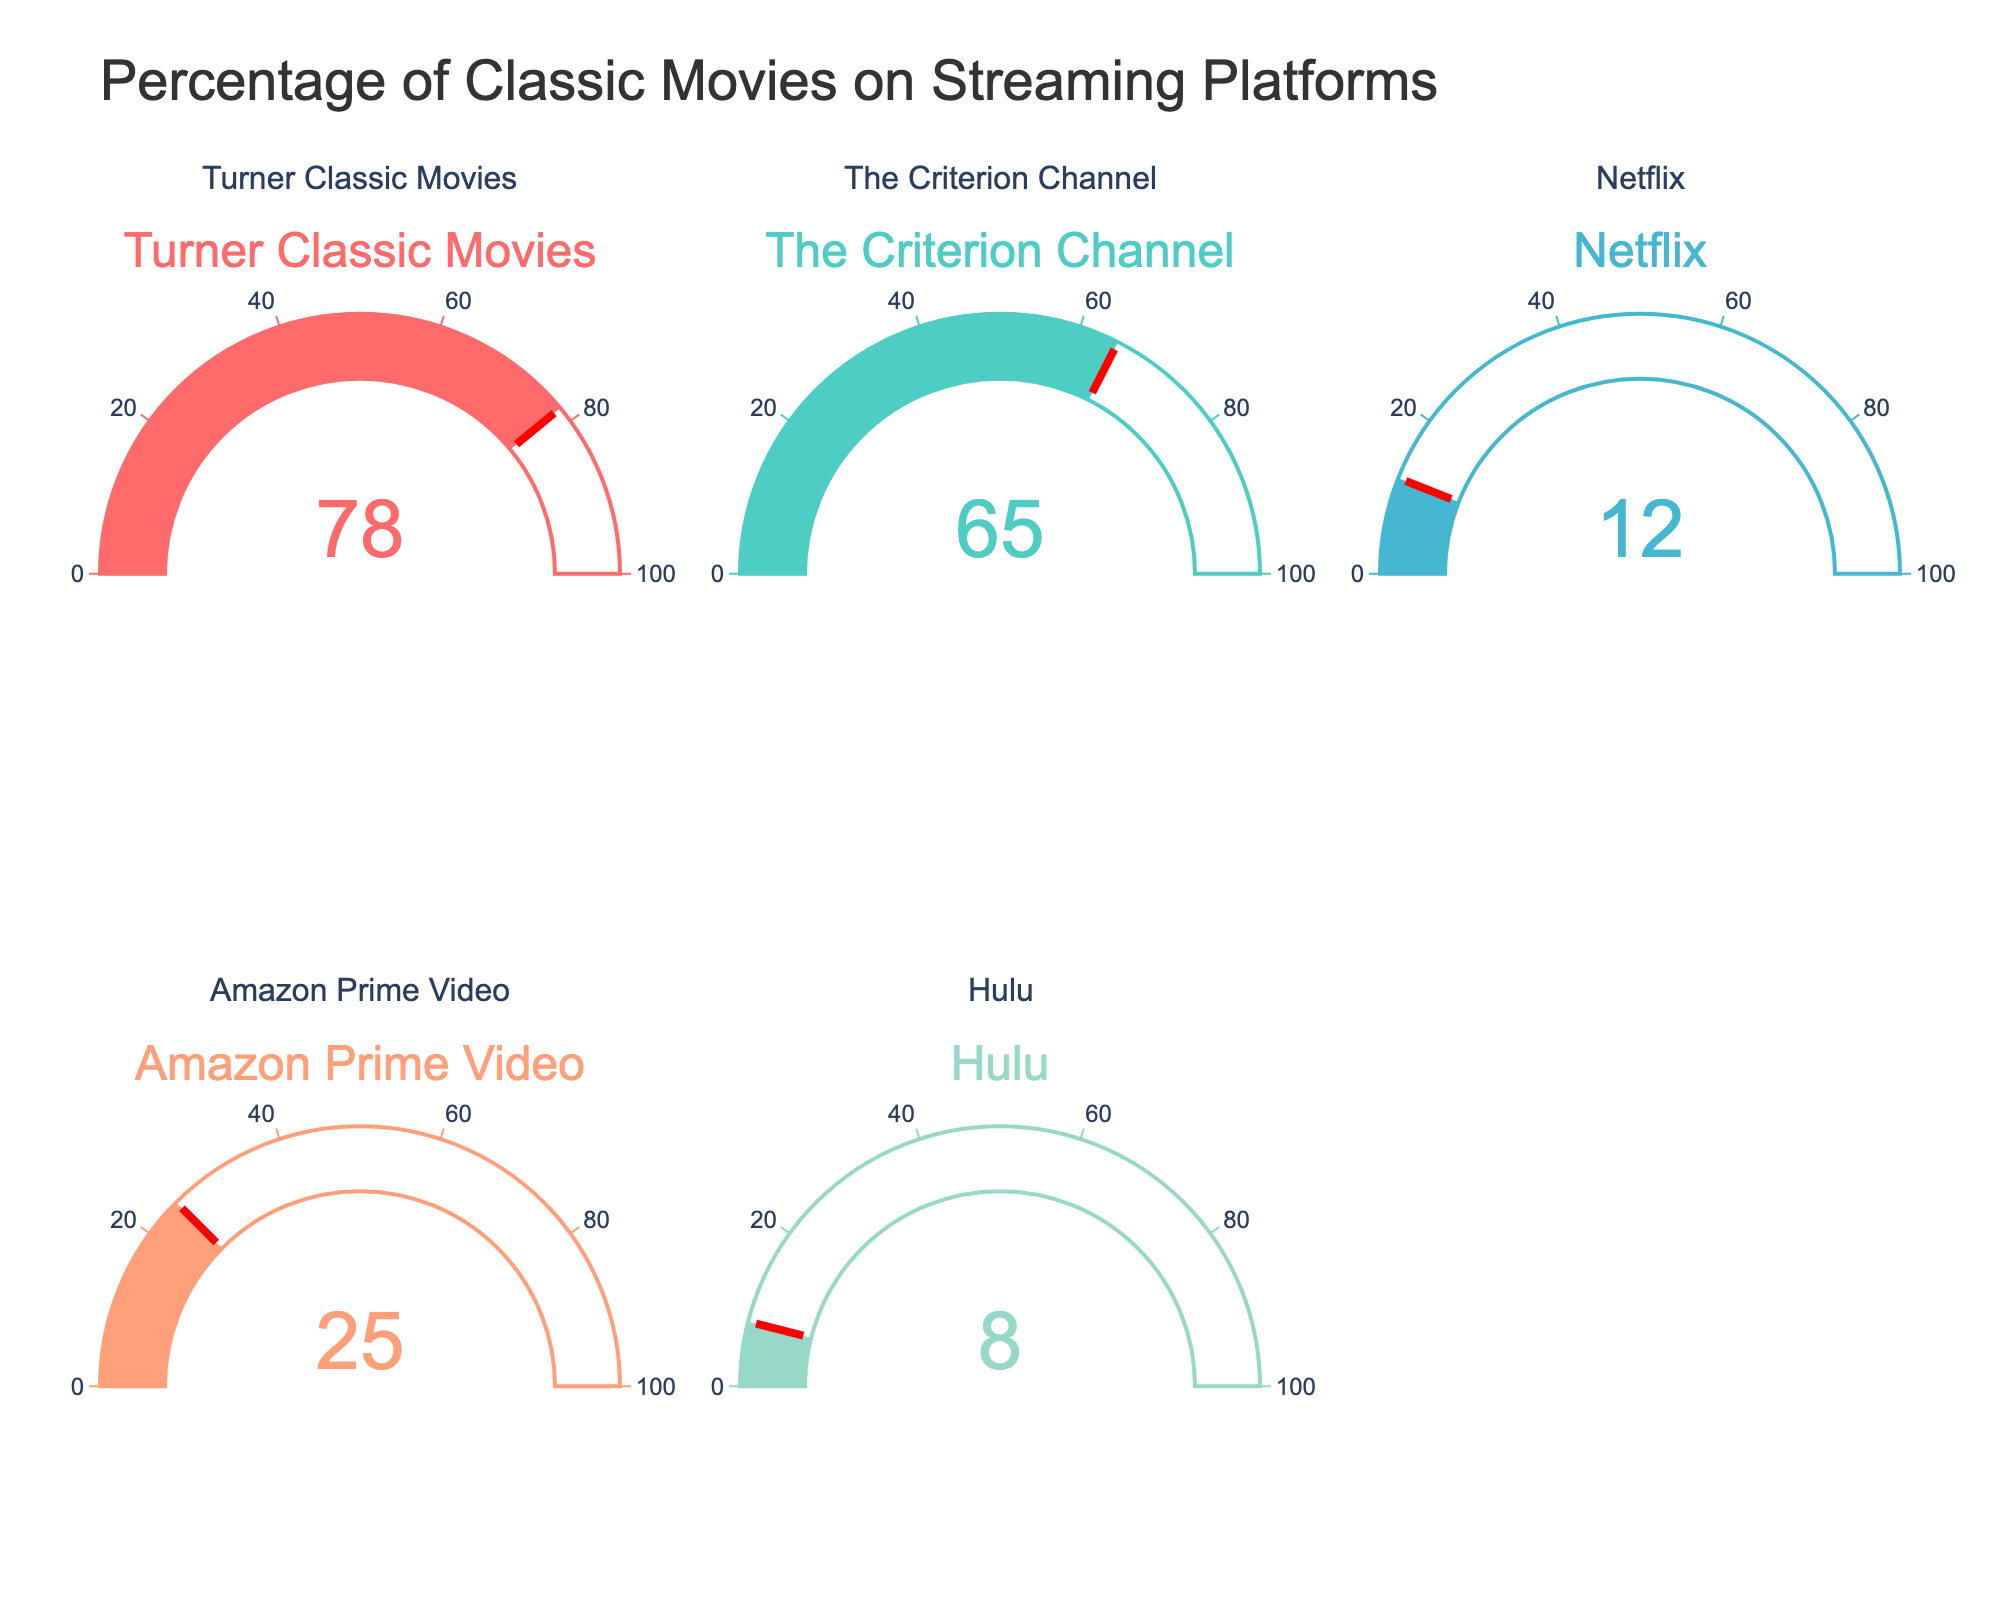What's the highest percentage of classic movies available on any platform? The highest percentage can be found by looking at each gauge and identifying the one with the largest number. In this case, Turner Classic Movies has the highest percentage at 78.
Answer: 78 What's the title of the figure? The title of the figure is displayed at the top of the chart. It reads "Percentage of Classic Movies on Streaming Platforms".
Answer: Percentage of Classic Movies on Streaming Platforms Which platform has the lowest percentage of classic movies? By comparing the values on each gauge, Hulu has the lowest percentage of classic movies available at 8.
Answer: Hulu What is the average percentage of classic movies available across all platforms? Add each platform's percentage and divide by the number of platforms: (78 + 65 + 12 + 25 + 8) / 5 = 188 / 5 = 37.6.
Answer: 37.6 How many platforms are presented in the figure? The figure shows a total of 5 different streaming platforms. This can be verified by counting the number of gauges.
Answer: 5 What is the percentage of classic movies available on a platform compared to Turner Classic Movies (78%)? For each platform, divide its percentage by 78 and multiply by 100 to get the percentage with respect to Turner Classic Movies.
- Criterion Channel: (65 / 78) * 100 ≈ 83.33
- Netflix: (12 / 78) * 100 ≈ 15.38
- Amazon Prime Video: (25 / 78) * 100 ≈ 32.05
- Hulu: (8 / 78) * 100 ≈ 10.26
Answer: Criterion Channel: 83.33, Netflix: 15.38, Amazon Prime Video: 32.05, Hulu: 10.26 What's the difference between the highest and lowest percentage values? Subtract the lowest percentage value (Hulu, 8) from the highest percentage value (Turner Classic Movies, 78): 78 - 8 = 70.
Answer: 70 Compare Turner Classic Movies and Amazon Prime Video in terms of classic movie availability percentage. Turner Classic Movies has a value of 78%, while Amazon Prime Video has 25%, so Turner Classic Movies has 53% more classic movies available than Amazon Prime Video (78 - 25 = 53).
Answer: Turner Classic Movies has 53% more Which platforms have a classic movie availability percentage greater than the overall average? The overall average percentage is 37.6. Platforms with percentages greater than 37.6 are Turner Classic Movies (78%) and Criterion Channel (65%).
Answer: Turner Classic Movies, Criterion Channel 